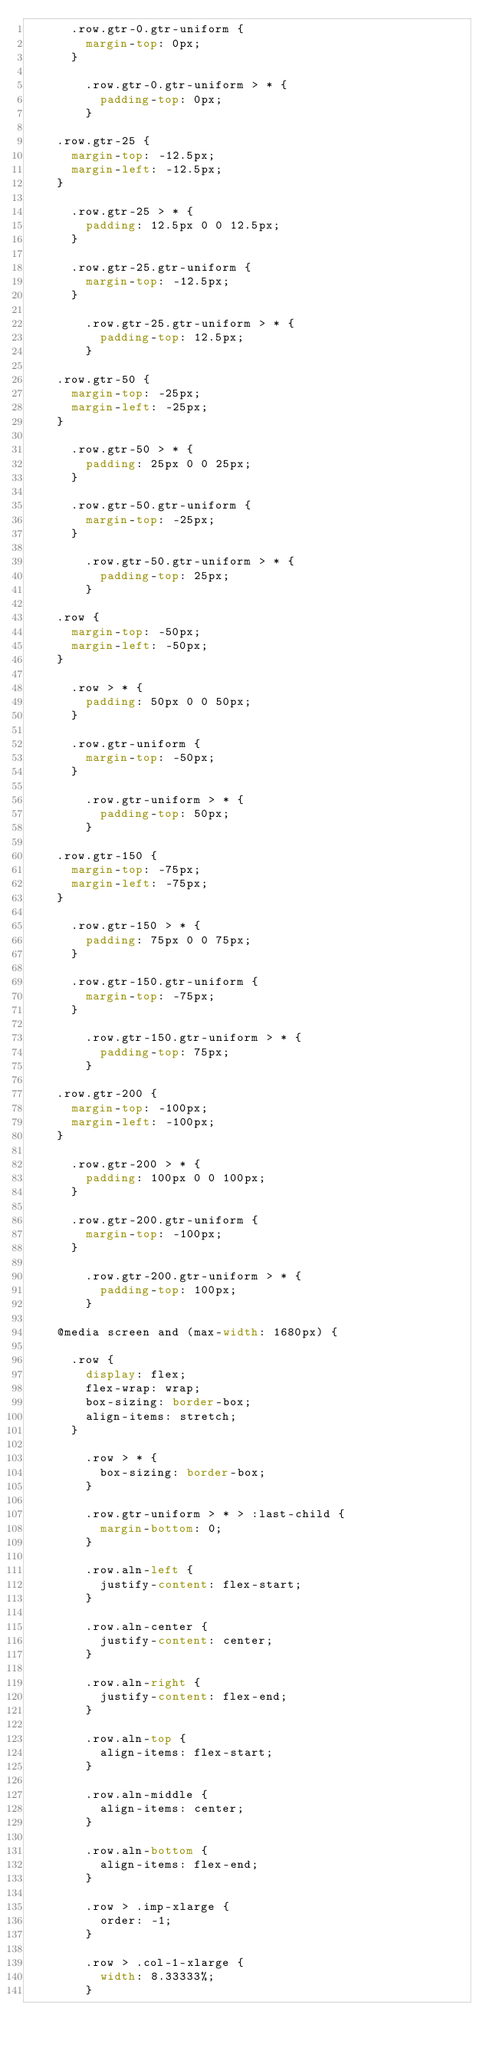Convert code to text. <code><loc_0><loc_0><loc_500><loc_500><_CSS_>			.row.gtr-0.gtr-uniform {
				margin-top: 0px;
			}

				.row.gtr-0.gtr-uniform > * {
					padding-top: 0px;
				}

		.row.gtr-25 {
			margin-top: -12.5px;
			margin-left: -12.5px;
		}

			.row.gtr-25 > * {
				padding: 12.5px 0 0 12.5px;
			}

			.row.gtr-25.gtr-uniform {
				margin-top: -12.5px;
			}

				.row.gtr-25.gtr-uniform > * {
					padding-top: 12.5px;
				}

		.row.gtr-50 {
			margin-top: -25px;
			margin-left: -25px;
		}

			.row.gtr-50 > * {
				padding: 25px 0 0 25px;
			}

			.row.gtr-50.gtr-uniform {
				margin-top: -25px;
			}

				.row.gtr-50.gtr-uniform > * {
					padding-top: 25px;
				}

		.row {
			margin-top: -50px;
			margin-left: -50px;
		}

			.row > * {
				padding: 50px 0 0 50px;
			}

			.row.gtr-uniform {
				margin-top: -50px;
			}

				.row.gtr-uniform > * {
					padding-top: 50px;
				}

		.row.gtr-150 {
			margin-top: -75px;
			margin-left: -75px;
		}

			.row.gtr-150 > * {
				padding: 75px 0 0 75px;
			}

			.row.gtr-150.gtr-uniform {
				margin-top: -75px;
			}

				.row.gtr-150.gtr-uniform > * {
					padding-top: 75px;
				}

		.row.gtr-200 {
			margin-top: -100px;
			margin-left: -100px;
		}

			.row.gtr-200 > * {
				padding: 100px 0 0 100px;
			}

			.row.gtr-200.gtr-uniform {
				margin-top: -100px;
			}

				.row.gtr-200.gtr-uniform > * {
					padding-top: 100px;
				}

		@media screen and (max-width: 1680px) {

			.row {
				display: flex;
				flex-wrap: wrap;
				box-sizing: border-box;
				align-items: stretch;
			}

				.row > * {
					box-sizing: border-box;
				}

				.row.gtr-uniform > * > :last-child {
					margin-bottom: 0;
				}

				.row.aln-left {
					justify-content: flex-start;
				}

				.row.aln-center {
					justify-content: center;
				}

				.row.aln-right {
					justify-content: flex-end;
				}

				.row.aln-top {
					align-items: flex-start;
				}

				.row.aln-middle {
					align-items: center;
				}

				.row.aln-bottom {
					align-items: flex-end;
				}

				.row > .imp-xlarge {
					order: -1;
				}

				.row > .col-1-xlarge {
					width: 8.33333%;
				}
</code> 